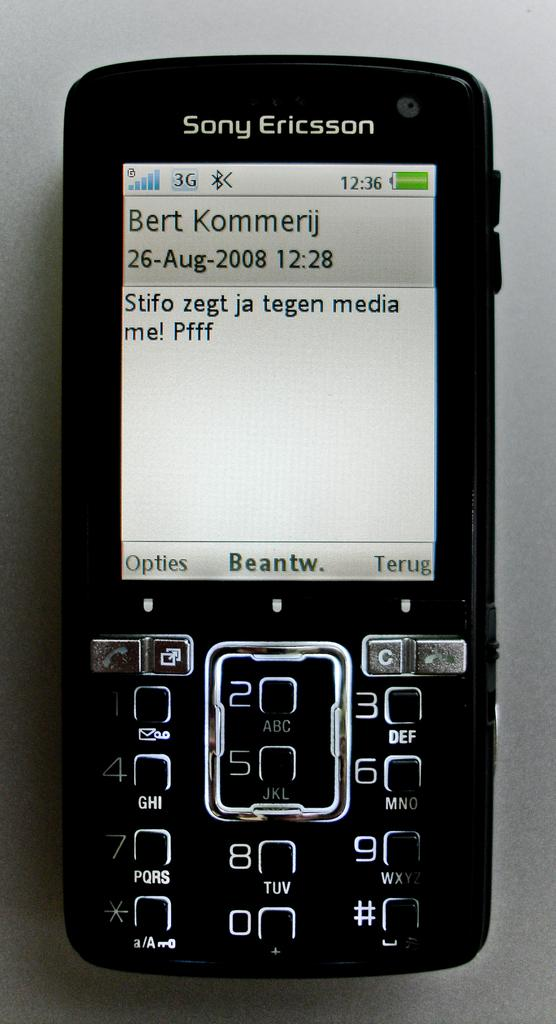<image>
Present a compact description of the photo's key features. The owner of this Sony Ericsson phone has sent a message to,or received a message from Bert Kommerij 